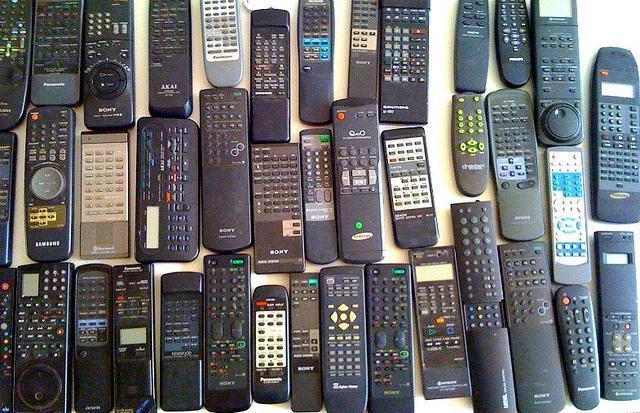Most of these items are probably used on what?
Indicate the correct choice and explain in the format: 'Answer: answer
Rationale: rationale.'
Options: Televisions, cars, light fixtures, air conditioners. Answer: televisions.
Rationale: These devices all have the number of buttons needed and layout suggestive of being television remotes. 